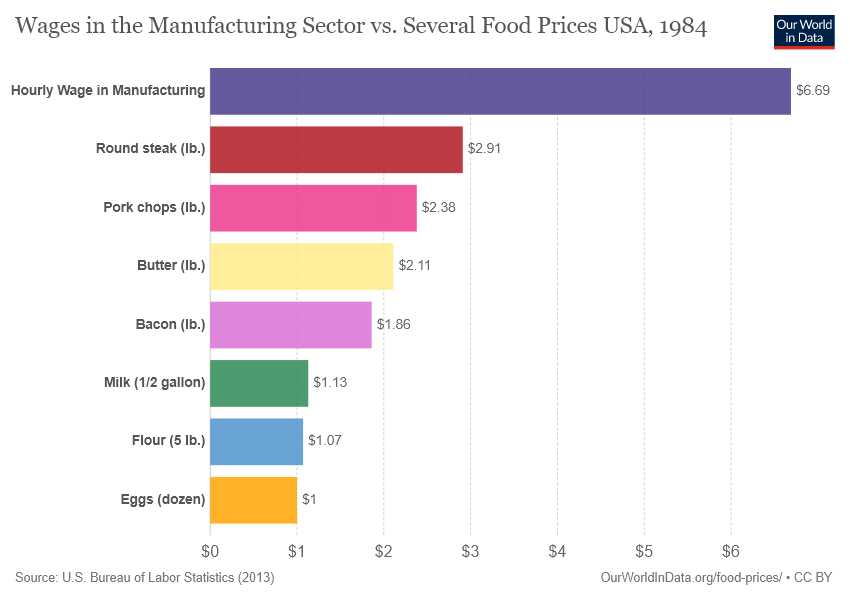Mention a couple of crucial points in this snapshot. The average of the two smallest bars is 1.035, with no significant digits being displayed. There are a total of 8 categories in the chart. 